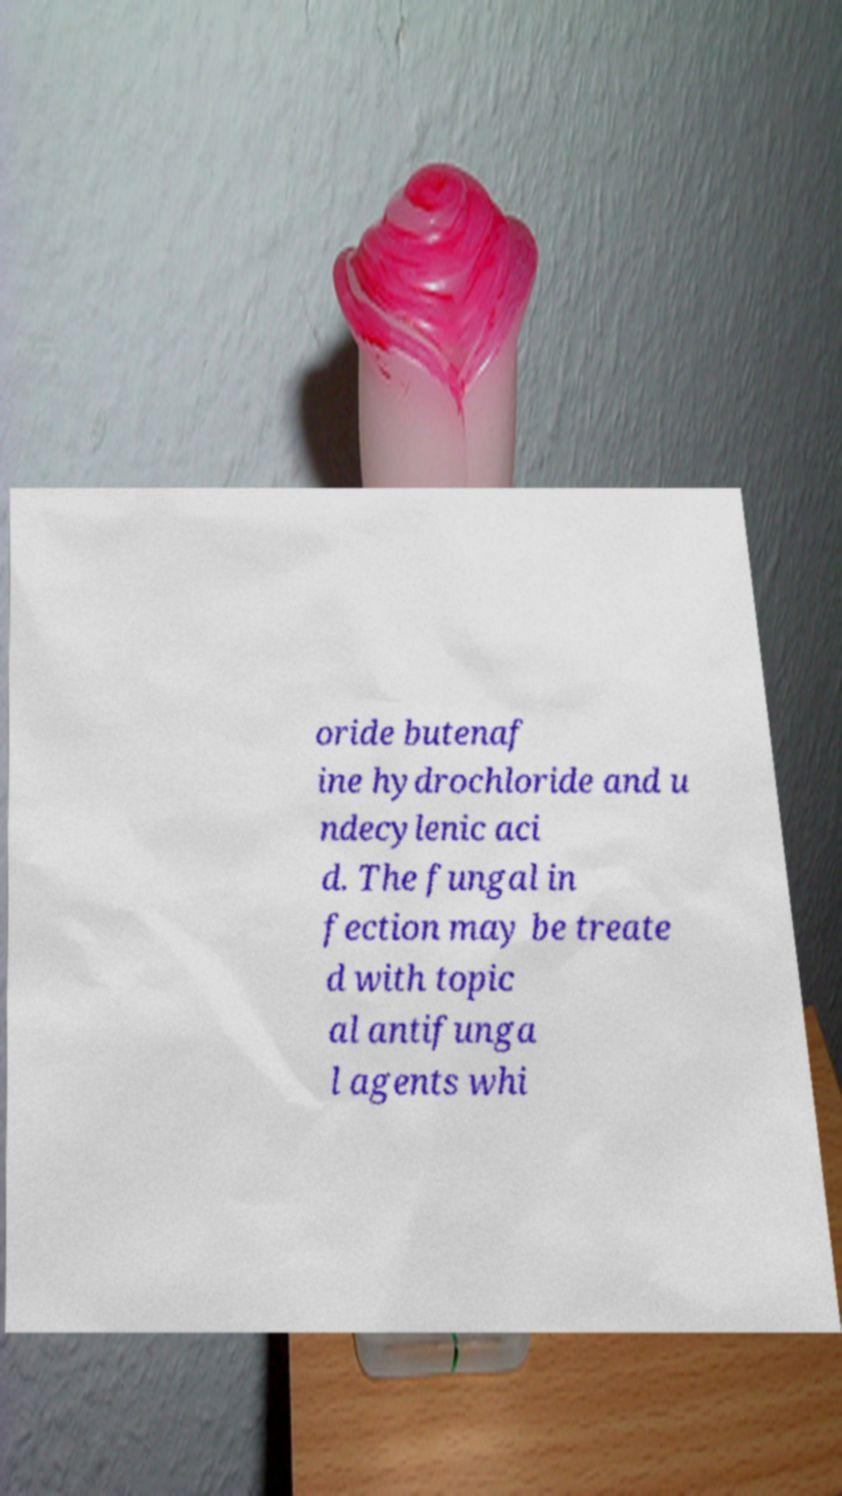Can you accurately transcribe the text from the provided image for me? oride butenaf ine hydrochloride and u ndecylenic aci d. The fungal in fection may be treate d with topic al antifunga l agents whi 